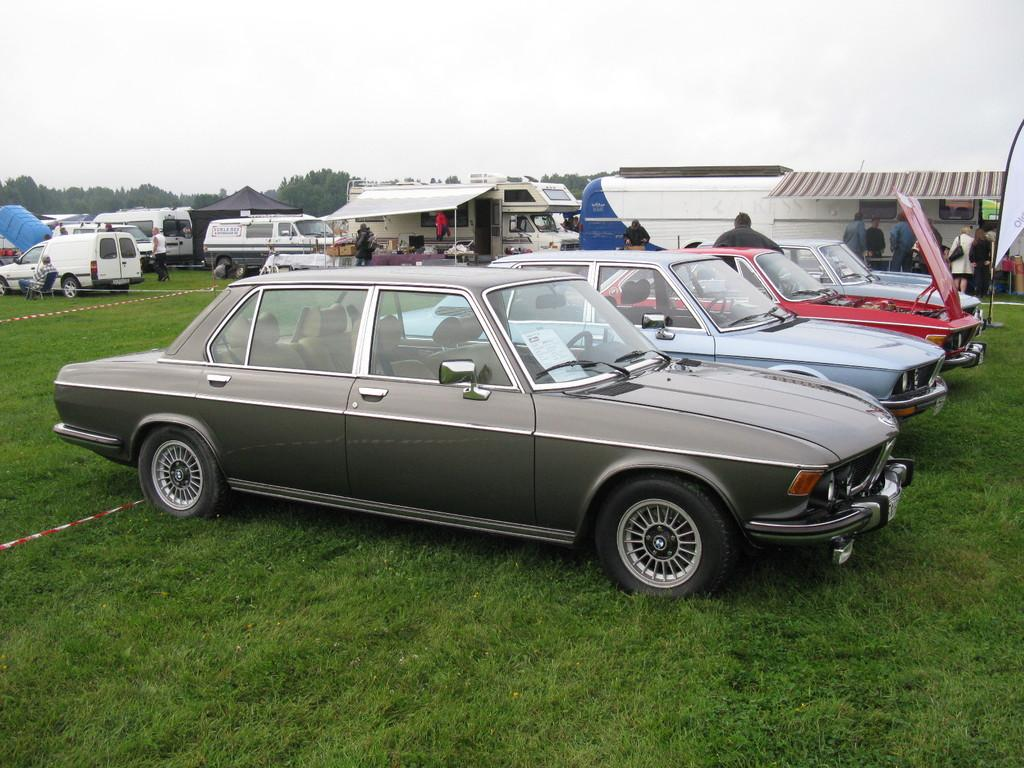What can be seen in the image? There are vehicles in the image. Can you describe one of the vehicles? One vehicle is gray in color. What else is visible in the background of the image? There are people standing and trees with green color in the background. How would you describe the sky in the image? The sky is white in color. Is there a lake visible in the image? No, there is no lake present in the image. 